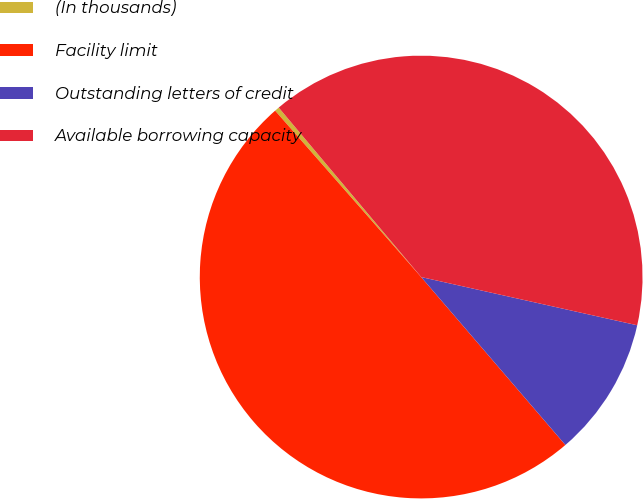<chart> <loc_0><loc_0><loc_500><loc_500><pie_chart><fcel>(In thousands)<fcel>Facility limit<fcel>Outstanding letters of credit<fcel>Available borrowing capacity<nl><fcel>0.34%<fcel>49.83%<fcel>10.21%<fcel>39.62%<nl></chart> 